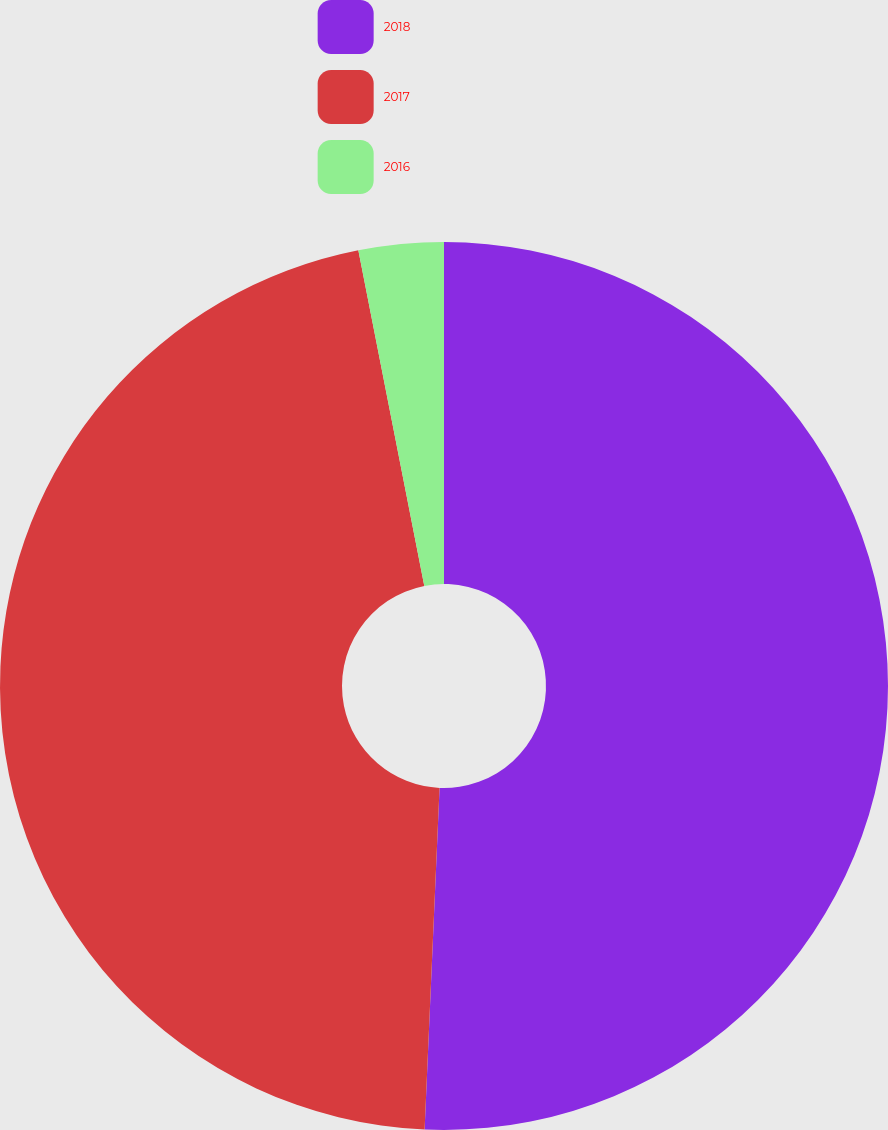Convert chart to OTSL. <chart><loc_0><loc_0><loc_500><loc_500><pie_chart><fcel>2018<fcel>2017<fcel>2016<nl><fcel>50.69%<fcel>46.21%<fcel>3.09%<nl></chart> 